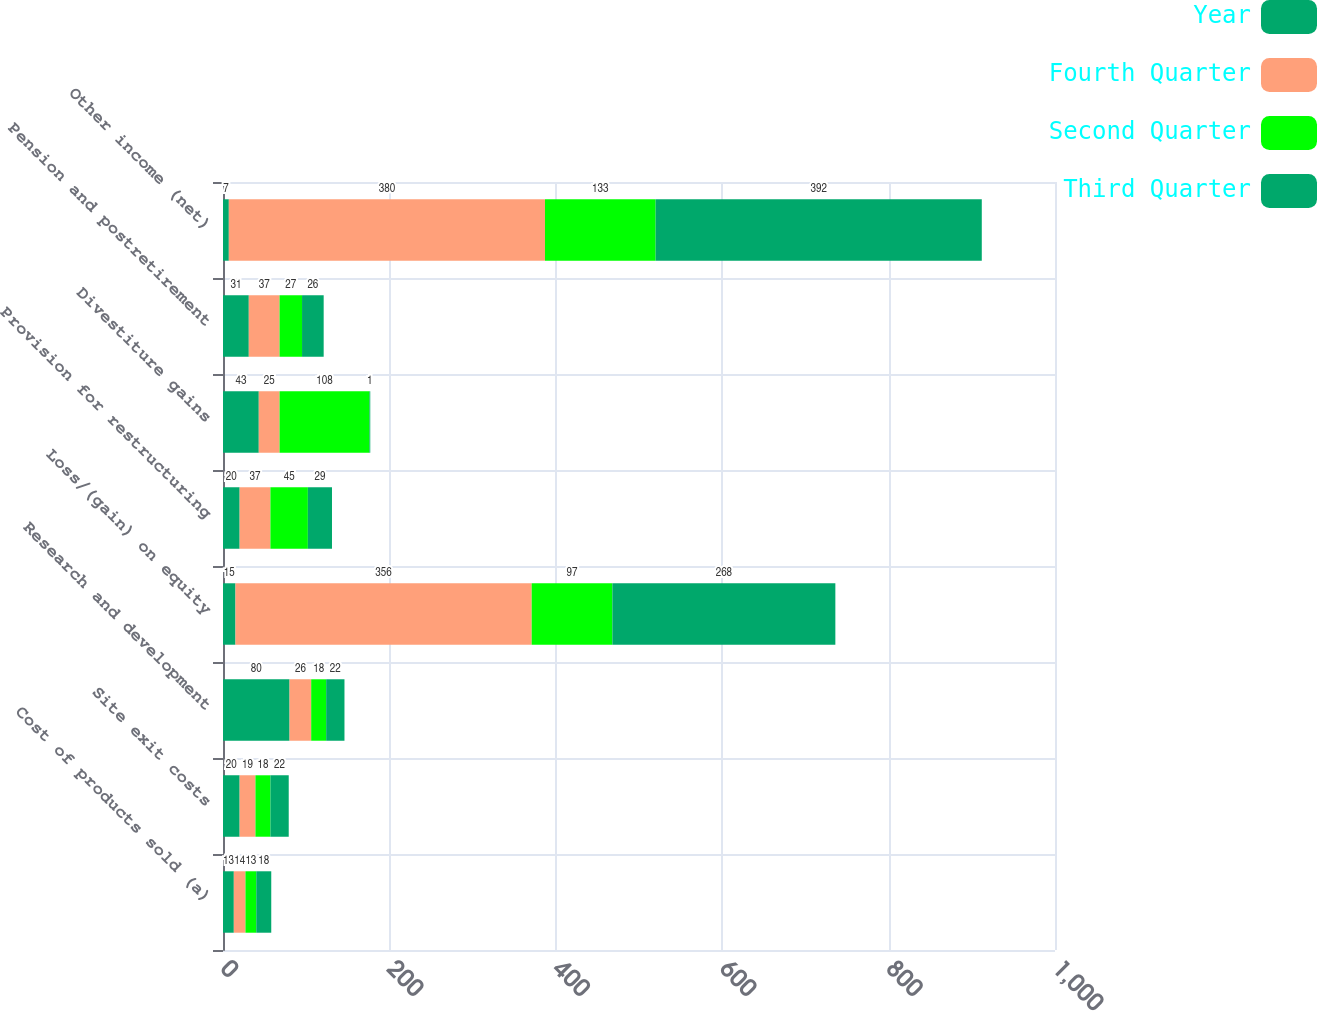Convert chart to OTSL. <chart><loc_0><loc_0><loc_500><loc_500><stacked_bar_chart><ecel><fcel>Cost of products sold (a)<fcel>Site exit costs<fcel>Research and development<fcel>Loss/(gain) on equity<fcel>Provision for restructuring<fcel>Divestiture gains<fcel>Pension and postretirement<fcel>Other income (net)<nl><fcel>Year<fcel>13<fcel>20<fcel>80<fcel>15<fcel>20<fcel>43<fcel>31<fcel>7<nl><fcel>Fourth Quarter<fcel>14<fcel>19<fcel>26<fcel>356<fcel>37<fcel>25<fcel>37<fcel>380<nl><fcel>Second Quarter<fcel>13<fcel>18<fcel>18<fcel>97<fcel>45<fcel>108<fcel>27<fcel>133<nl><fcel>Third Quarter<fcel>18<fcel>22<fcel>22<fcel>268<fcel>29<fcel>1<fcel>26<fcel>392<nl></chart> 